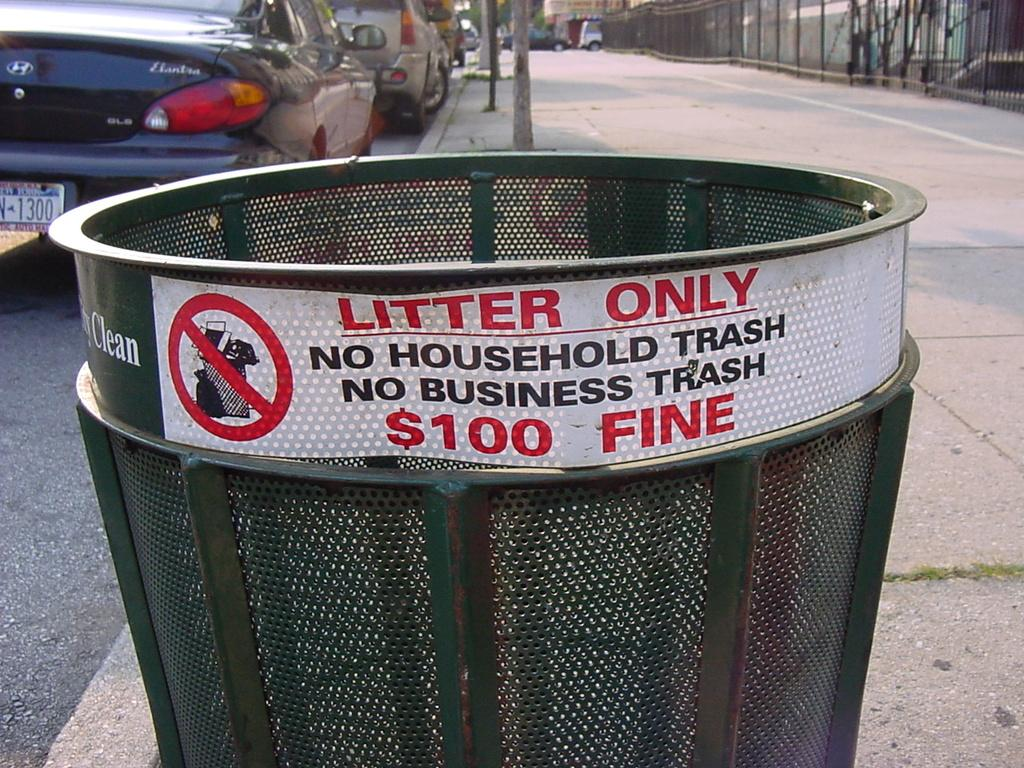<image>
Offer a succinct explanation of the picture presented. A trash can on a street has sticker on it that reads LITTER ONLY. 